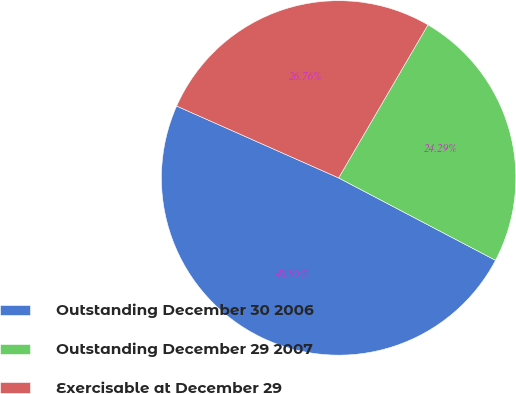Convert chart. <chart><loc_0><loc_0><loc_500><loc_500><pie_chart><fcel>Outstanding December 30 2006<fcel>Outstanding December 29 2007<fcel>Exercisable at December 29<nl><fcel>48.95%<fcel>24.29%<fcel>26.76%<nl></chart> 